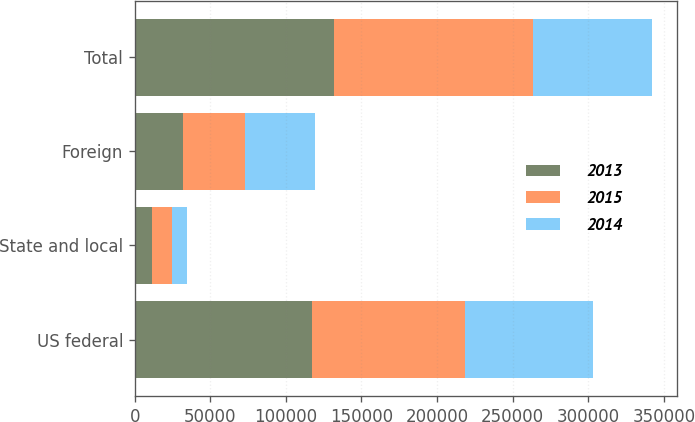<chart> <loc_0><loc_0><loc_500><loc_500><stacked_bar_chart><ecel><fcel>US federal<fcel>State and local<fcel>Foreign<fcel>Total<nl><fcel>2013<fcel>117602<fcel>11175<fcel>31981<fcel>131875<nl><fcel>2015<fcel>100826<fcel>13686<fcel>41151<fcel>131637<nl><fcel>2014<fcel>84686<fcel>9774<fcel>46450<fcel>78385<nl></chart> 